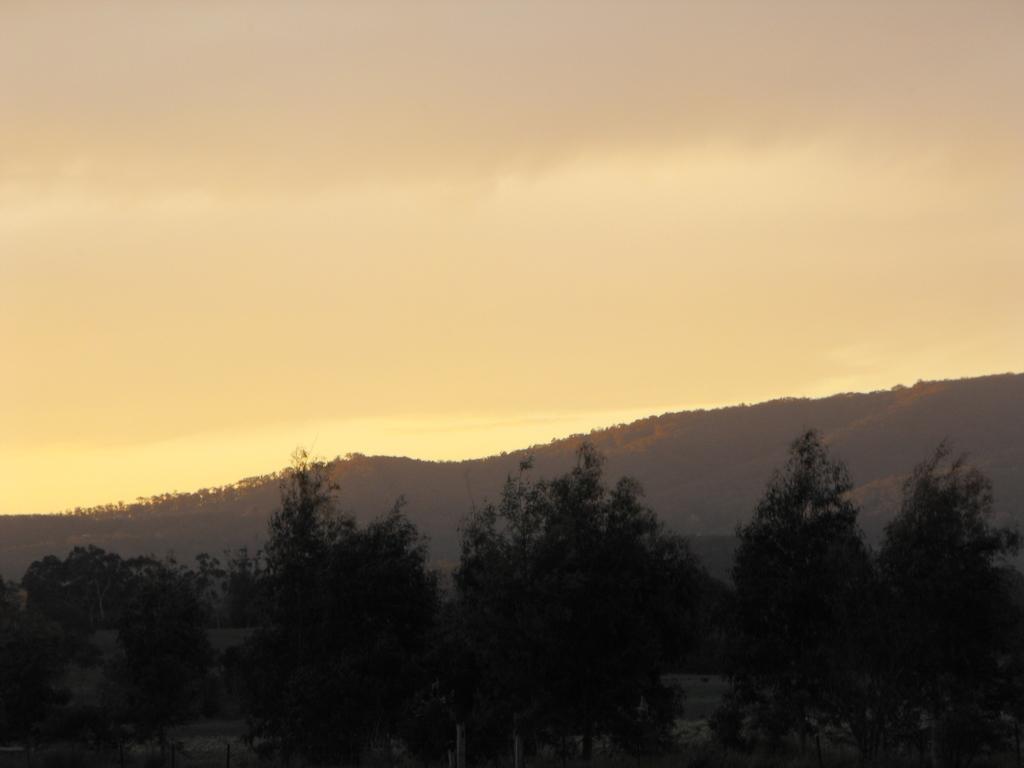Describe this image in one or two sentences. In this image there are many trees and hills. There is a slightly cloudy sky. 